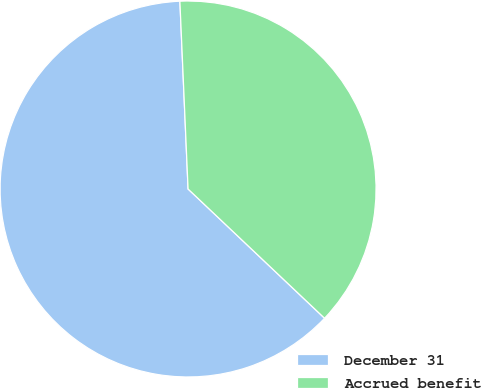<chart> <loc_0><loc_0><loc_500><loc_500><pie_chart><fcel>December 31<fcel>Accrued benefit<nl><fcel>62.24%<fcel>37.76%<nl></chart> 